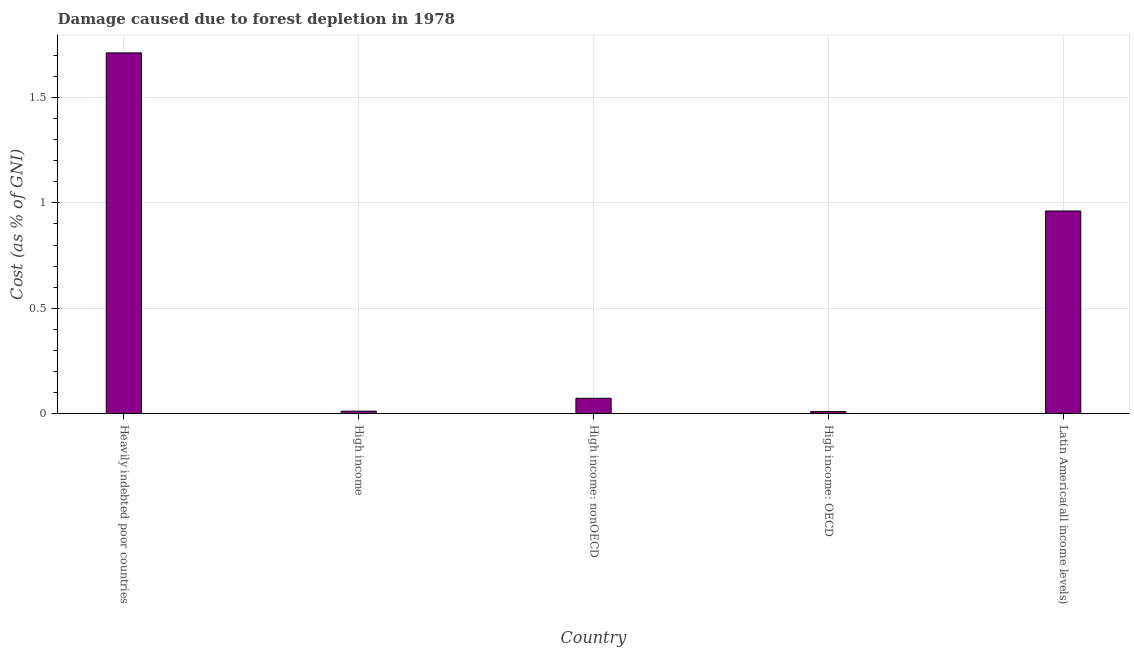Does the graph contain grids?
Your answer should be very brief. Yes. What is the title of the graph?
Provide a short and direct response. Damage caused due to forest depletion in 1978. What is the label or title of the X-axis?
Make the answer very short. Country. What is the label or title of the Y-axis?
Your answer should be very brief. Cost (as % of GNI). What is the damage caused due to forest depletion in High income: nonOECD?
Provide a succinct answer. 0.07. Across all countries, what is the maximum damage caused due to forest depletion?
Your answer should be compact. 1.71. Across all countries, what is the minimum damage caused due to forest depletion?
Give a very brief answer. 0.01. In which country was the damage caused due to forest depletion maximum?
Make the answer very short. Heavily indebted poor countries. In which country was the damage caused due to forest depletion minimum?
Provide a short and direct response. High income: OECD. What is the sum of the damage caused due to forest depletion?
Your response must be concise. 2.77. What is the difference between the damage caused due to forest depletion in High income: nonOECD and Latin America(all income levels)?
Offer a very short reply. -0.89. What is the average damage caused due to forest depletion per country?
Offer a terse response. 0.55. What is the median damage caused due to forest depletion?
Provide a succinct answer. 0.07. In how many countries, is the damage caused due to forest depletion greater than 1.2 %?
Your response must be concise. 1. What is the ratio of the damage caused due to forest depletion in High income to that in High income: OECD?
Provide a succinct answer. 1.21. Is the damage caused due to forest depletion in High income: OECD less than that in Latin America(all income levels)?
Offer a terse response. Yes. What is the difference between the highest and the second highest damage caused due to forest depletion?
Provide a short and direct response. 0.75. Is the sum of the damage caused due to forest depletion in High income: nonOECD and Latin America(all income levels) greater than the maximum damage caused due to forest depletion across all countries?
Make the answer very short. No. What is the difference between the highest and the lowest damage caused due to forest depletion?
Keep it short and to the point. 1.7. In how many countries, is the damage caused due to forest depletion greater than the average damage caused due to forest depletion taken over all countries?
Your response must be concise. 2. How many bars are there?
Offer a very short reply. 5. Are the values on the major ticks of Y-axis written in scientific E-notation?
Your answer should be very brief. No. What is the Cost (as % of GNI) of Heavily indebted poor countries?
Your answer should be very brief. 1.71. What is the Cost (as % of GNI) in High income?
Offer a terse response. 0.01. What is the Cost (as % of GNI) of High income: nonOECD?
Offer a terse response. 0.07. What is the Cost (as % of GNI) of High income: OECD?
Provide a short and direct response. 0.01. What is the Cost (as % of GNI) in Latin America(all income levels)?
Provide a succinct answer. 0.96. What is the difference between the Cost (as % of GNI) in Heavily indebted poor countries and High income?
Give a very brief answer. 1.7. What is the difference between the Cost (as % of GNI) in Heavily indebted poor countries and High income: nonOECD?
Offer a very short reply. 1.64. What is the difference between the Cost (as % of GNI) in Heavily indebted poor countries and High income: OECD?
Provide a succinct answer. 1.7. What is the difference between the Cost (as % of GNI) in Heavily indebted poor countries and Latin America(all income levels)?
Provide a short and direct response. 0.75. What is the difference between the Cost (as % of GNI) in High income and High income: nonOECD?
Provide a short and direct response. -0.06. What is the difference between the Cost (as % of GNI) in High income and High income: OECD?
Make the answer very short. 0. What is the difference between the Cost (as % of GNI) in High income and Latin America(all income levels)?
Make the answer very short. -0.95. What is the difference between the Cost (as % of GNI) in High income: nonOECD and High income: OECD?
Your answer should be very brief. 0.06. What is the difference between the Cost (as % of GNI) in High income: nonOECD and Latin America(all income levels)?
Provide a succinct answer. -0.89. What is the difference between the Cost (as % of GNI) in High income: OECD and Latin America(all income levels)?
Your answer should be very brief. -0.95. What is the ratio of the Cost (as % of GNI) in Heavily indebted poor countries to that in High income?
Provide a succinct answer. 140.14. What is the ratio of the Cost (as % of GNI) in Heavily indebted poor countries to that in High income: nonOECD?
Your answer should be very brief. 23.35. What is the ratio of the Cost (as % of GNI) in Heavily indebted poor countries to that in High income: OECD?
Offer a terse response. 168.95. What is the ratio of the Cost (as % of GNI) in Heavily indebted poor countries to that in Latin America(all income levels)?
Your answer should be compact. 1.78. What is the ratio of the Cost (as % of GNI) in High income to that in High income: nonOECD?
Make the answer very short. 0.17. What is the ratio of the Cost (as % of GNI) in High income to that in High income: OECD?
Make the answer very short. 1.21. What is the ratio of the Cost (as % of GNI) in High income to that in Latin America(all income levels)?
Keep it short and to the point. 0.01. What is the ratio of the Cost (as % of GNI) in High income: nonOECD to that in High income: OECD?
Your answer should be compact. 7.23. What is the ratio of the Cost (as % of GNI) in High income: nonOECD to that in Latin America(all income levels)?
Provide a short and direct response. 0.08. What is the ratio of the Cost (as % of GNI) in High income: OECD to that in Latin America(all income levels)?
Offer a very short reply. 0.01. 